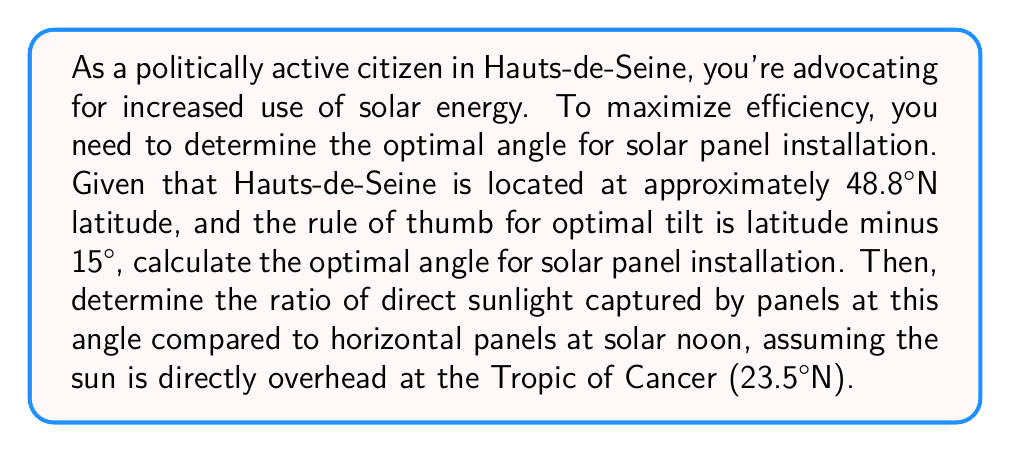Help me with this question. 1) First, calculate the optimal tilt angle:
   Optimal angle = Latitude - 15°
   $$ \theta = 48.8° - 15° = 33.8° $$

2) To find the ratio of direct sunlight captured, we need to compare the cosine of the angle between the sun's rays and the normal to the panel surface for both the tilted and horizontal panels.

3) For the tilted panels, the angle between the sun's rays and the normal to the panel is:
   $$ \alpha = 90° - (48.8° - 23.5°) - 33.8° = 31.5° $$

4) For horizontal panels, the angle is simply the complement of the sun's altitude:
   $$ \beta = 90° - (90° - (48.8° - 23.5°)) = 25.3° $$

5) The ratio of direct sunlight captured is:
   $$ \frac{\cos(31.5°)}{\cos(25.3°)} \approx 0.8519 / 0.9044 \approx 0.9420 $$

6) Convert to a percentage:
   $$ 0.9420 \times 100\% = 94.20\% $$

This means the tilted panels capture about 94.20% of the sunlight that horizontal panels would capture at solar noon.
Answer: 33.8°; 94.20% 